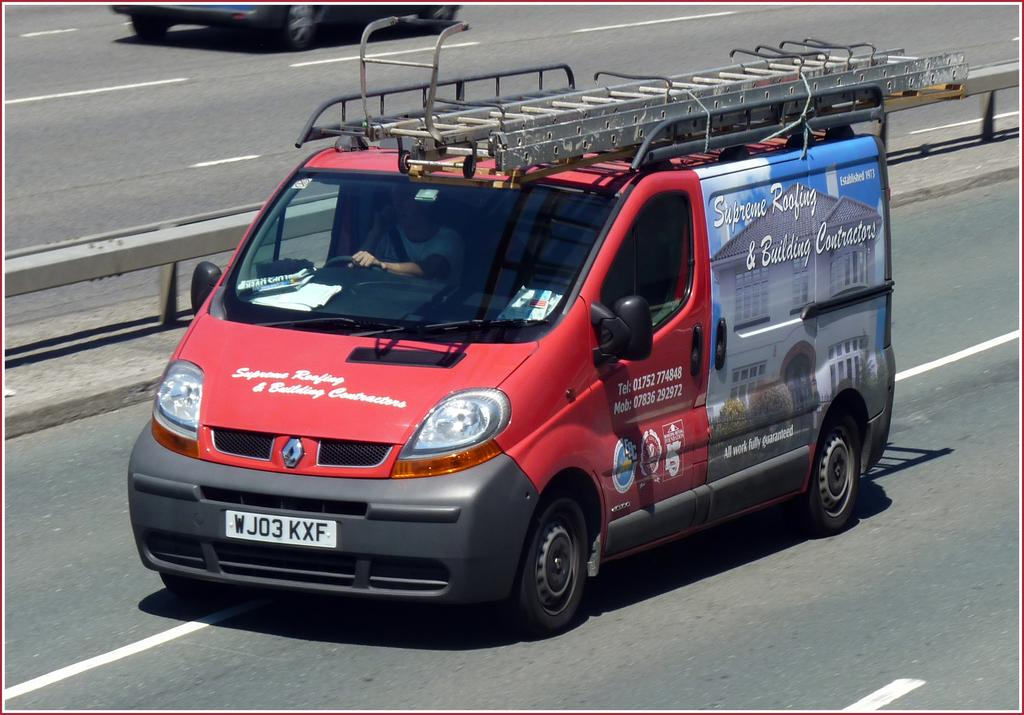What is the man in the image doing? The man is driving a truck in the image. Where is the truck located in the image? The truck is in the center of the image. What can be seen in the background of the image? There is a road and a railing visible in the background of the image. Can you describe the vehicle at the top of the image? Unfortunately, there is no information about a vehicle at the top of the image. What type of disease is the man driving the truck suffering from in the image? There is no information about the man's health or any diseases in the image. 